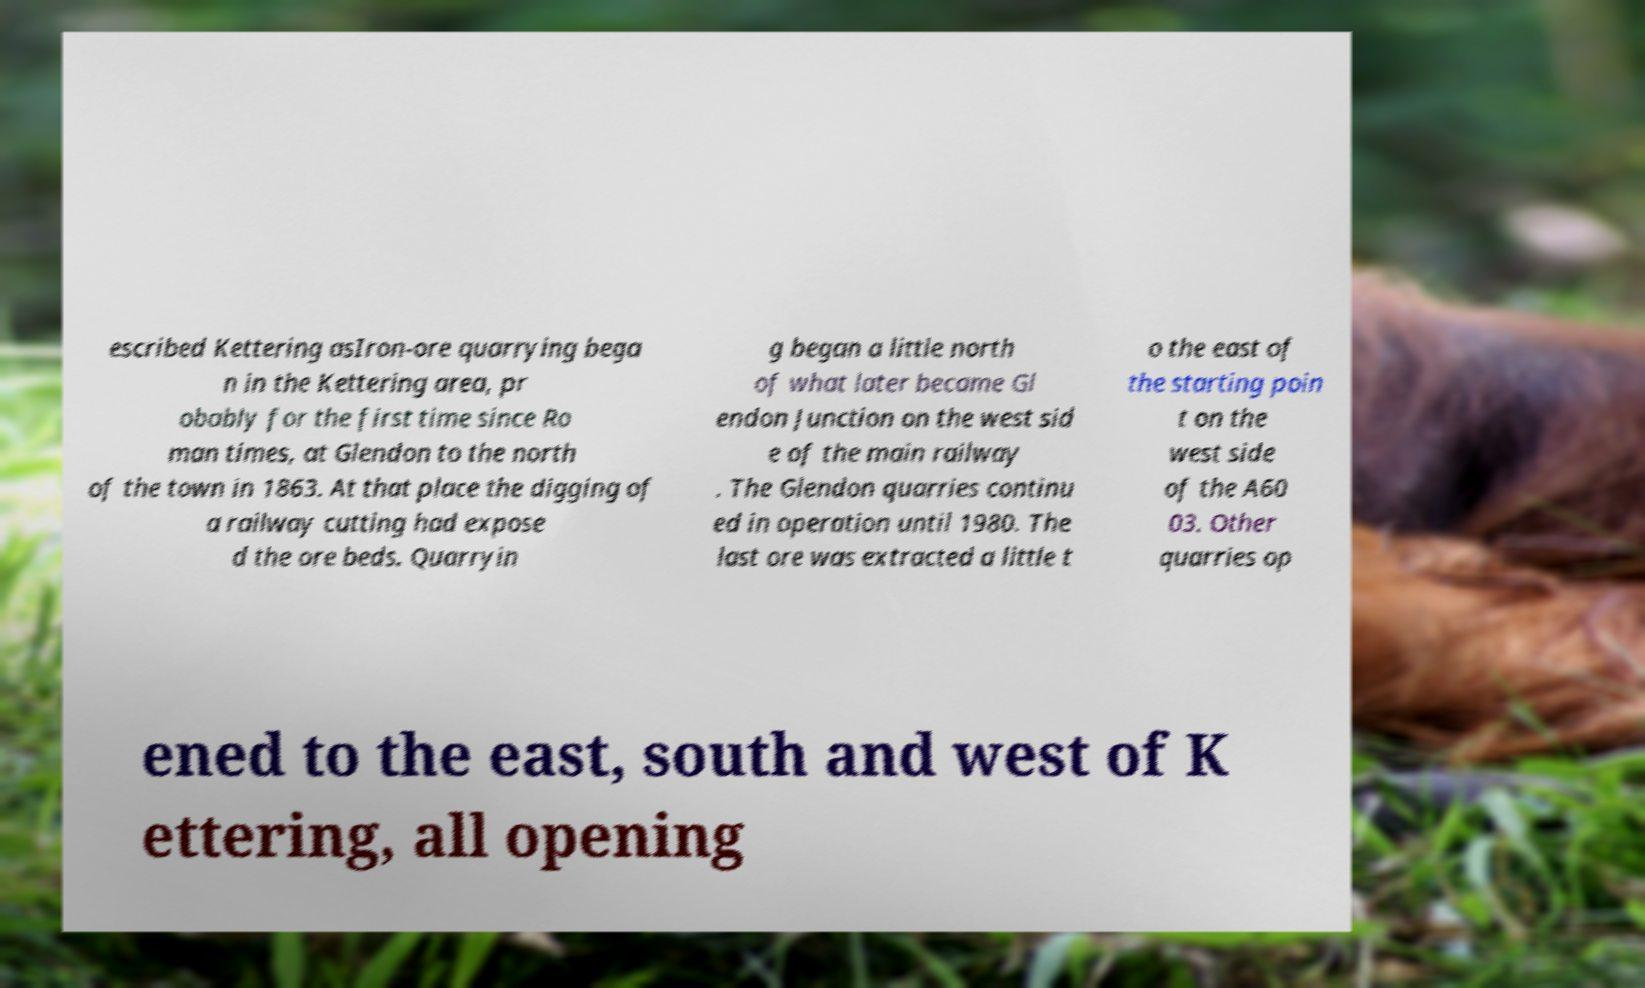Could you extract and type out the text from this image? escribed Kettering asIron-ore quarrying bega n in the Kettering area, pr obably for the first time since Ro man times, at Glendon to the north of the town in 1863. At that place the digging of a railway cutting had expose d the ore beds. Quarryin g began a little north of what later became Gl endon Junction on the west sid e of the main railway . The Glendon quarries continu ed in operation until 1980. The last ore was extracted a little t o the east of the starting poin t on the west side of the A60 03. Other quarries op ened to the east, south and west of K ettering, all opening 